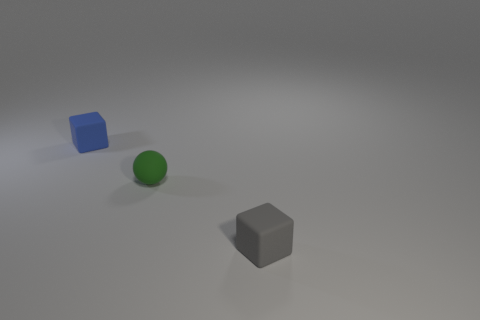Is there a purple shiny block of the same size as the blue matte object?
Make the answer very short. No. There is a gray block that is the same size as the green object; what is it made of?
Your answer should be compact. Rubber. What number of gray objects are left of the green rubber thing?
Provide a short and direct response. 0. There is a thing that is on the right side of the green sphere; is it the same shape as the tiny blue object?
Offer a terse response. Yes. Are there any other things that have the same shape as the small gray object?
Provide a short and direct response. Yes. What shape is the blue object that is behind the tiny thing that is on the right side of the green ball?
Keep it short and to the point. Cube. What number of gray things are made of the same material as the sphere?
Your answer should be compact. 1. There is a small cube that is made of the same material as the gray thing; what is its color?
Provide a short and direct response. Blue. Are there fewer green things than large blue rubber blocks?
Provide a short and direct response. No. What color is the other small matte object that is the same shape as the gray matte thing?
Your answer should be compact. Blue. 